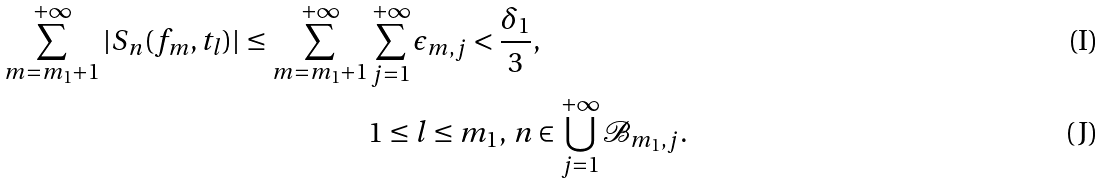Convert formula to latex. <formula><loc_0><loc_0><loc_500><loc_500>\sum _ { m = m _ { 1 } + 1 } ^ { + \infty } | S _ { n } ( f _ { m } , t _ { l } ) | \leq \sum _ { m = m _ { 1 } + 1 } ^ { + \infty } & \sum _ { j = 1 } ^ { + \infty } \epsilon _ { m , j } < \frac { \delta _ { 1 } } 3 , \\ & 1 \leq l \leq m _ { 1 } , \, n \in \bigcup _ { j = 1 } ^ { + \infty } \mathcal { B } _ { m _ { 1 } , j } .</formula> 